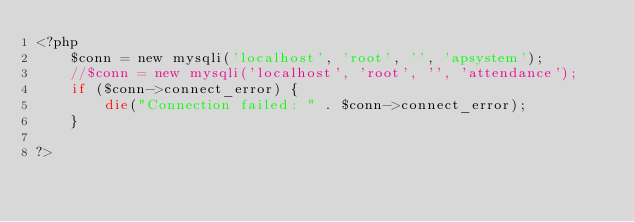Convert code to text. <code><loc_0><loc_0><loc_500><loc_500><_PHP_><?php
	$conn = new mysqli('localhost', 'root', '', 'apsystem');
	//$conn = new mysqli('localhost', 'root', '', 'attendance');
	if ($conn->connect_error) {
	    die("Connection failed: " . $conn->connect_error);
	}
	
?></code> 